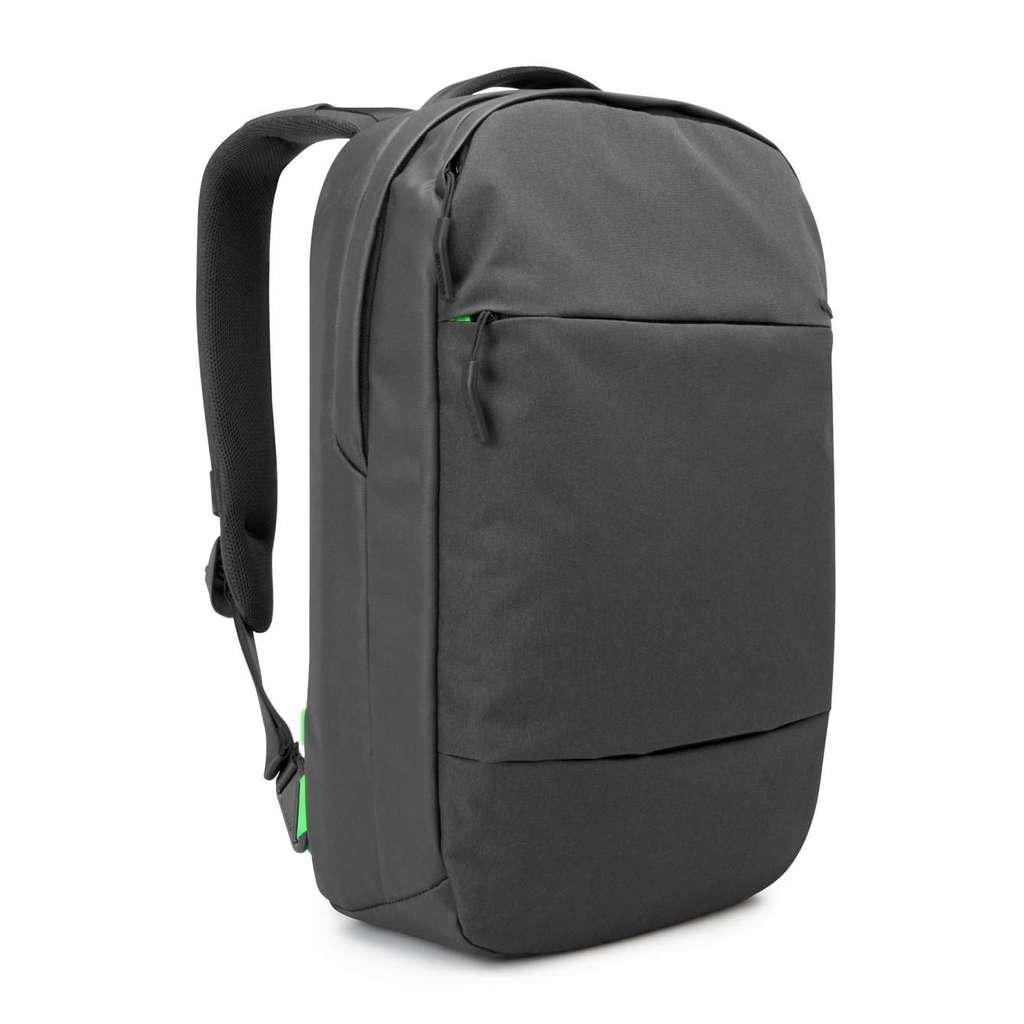Describe this image in one or two sentences. In this picture we can see a backpack which is in black color. 